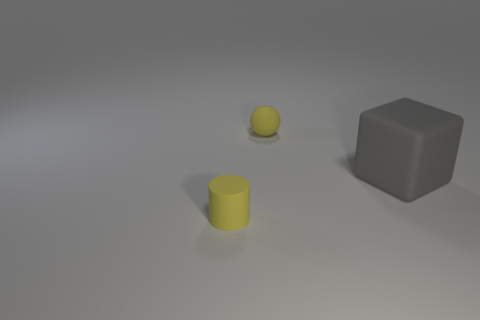Add 3 purple cubes. How many objects exist? 6 Subtract 0 purple blocks. How many objects are left? 3 Subtract all balls. How many objects are left? 2 Subtract 1 balls. How many balls are left? 0 Subtract all blue blocks. Subtract all cyan cylinders. How many blocks are left? 1 Subtract all big gray cubes. Subtract all small balls. How many objects are left? 1 Add 2 small rubber balls. How many small rubber balls are left? 3 Add 1 tiny yellow cylinders. How many tiny yellow cylinders exist? 2 